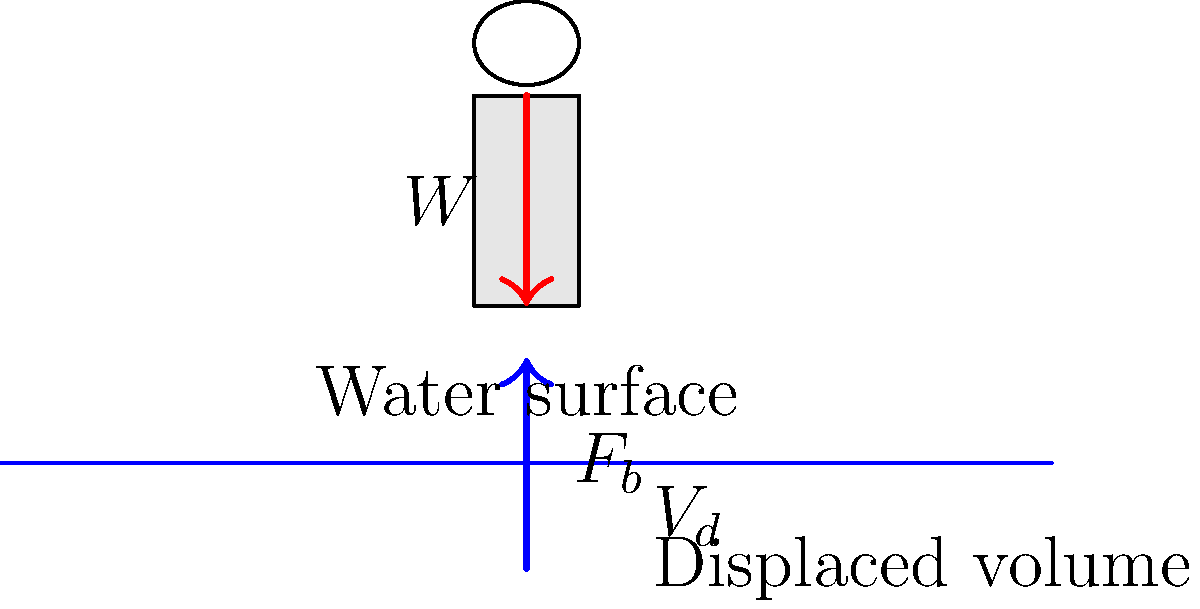In a therapeutic swimming pool, a person with a weight of 600 N is floating motionless. The density of the pool water is 1000 kg/m³. What volume of water does the person displace? To solve this problem, we'll use the concept of buoyancy and follow these steps:

1) For an object to float motionless, the buoyant force must equal the weight of the object:

   $F_b = W$

2) The buoyant force is equal to the weight of the displaced fluid:

   $F_b = \rho g V_d$

   Where:
   $\rho$ is the density of the fluid
   $g$ is the acceleration due to gravity
   $V_d$ is the volume of displaced fluid

3) Since $F_b = W$, we can write:

   $\rho g V_d = W$

4) Solve for $V_d$:

   $V_d = \frac{W}{\rho g}$

5) We know:
   $W = 600$ N
   $\rho = 1000$ kg/m³
   $g = 9.8$ m/s²

6) Substitute these values:

   $V_d = \frac{600 \text{ N}}{(1000 \text{ kg/m³})(9.8 \text{ m/s²})}$

7) Calculate:

   $V_d = 0.0612$ m³ or 61.2 L

Therefore, the person displaces 0.0612 m³ or 61.2 L of water.
Answer: 0.0612 m³ or 61.2 L 